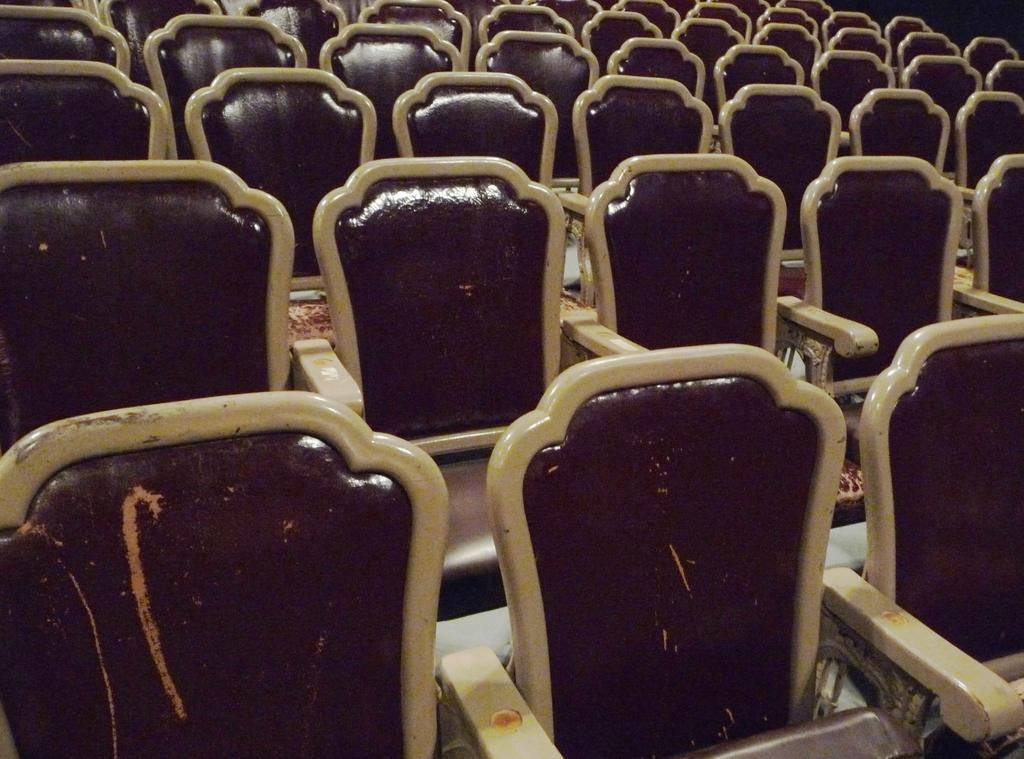What type of furniture is present in the image? There are many chairs in the image. What color are the chairs in the image? The chairs are brown in color. How many chickens can be seen in the image? There are no chickens present in the image. What type of house is depicted in the image? There is no house depicted in the image; it only shows chairs. 